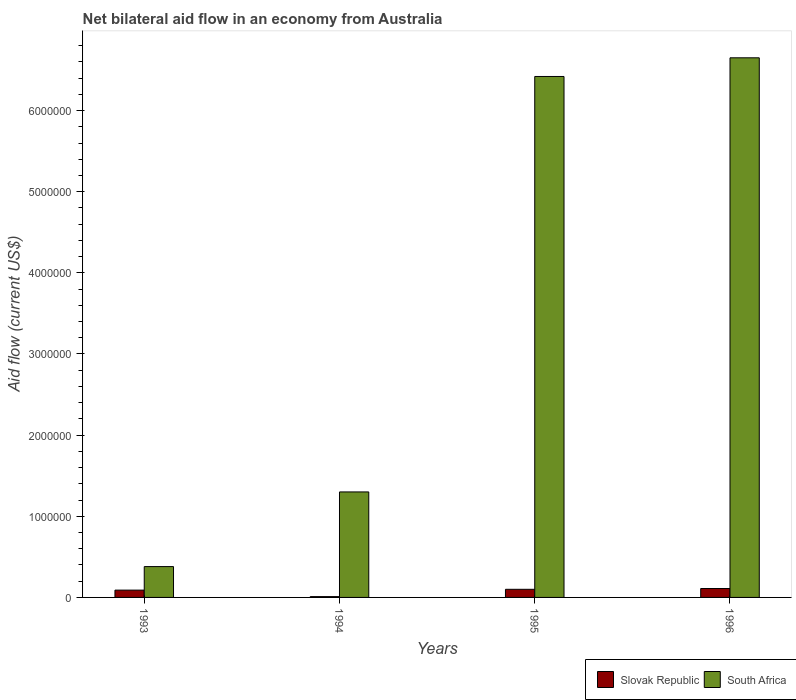Are the number of bars per tick equal to the number of legend labels?
Keep it short and to the point. Yes. How many bars are there on the 1st tick from the right?
Your response must be concise. 2. What is the label of the 1st group of bars from the left?
Your answer should be compact. 1993. Across all years, what is the maximum net bilateral aid flow in Slovak Republic?
Offer a very short reply. 1.10e+05. Across all years, what is the minimum net bilateral aid flow in South Africa?
Your answer should be compact. 3.80e+05. In which year was the net bilateral aid flow in South Africa maximum?
Your answer should be very brief. 1996. What is the total net bilateral aid flow in South Africa in the graph?
Give a very brief answer. 1.48e+07. What is the difference between the net bilateral aid flow in South Africa in 1994 and that in 1995?
Your response must be concise. -5.12e+06. What is the difference between the net bilateral aid flow in South Africa in 1996 and the net bilateral aid flow in Slovak Republic in 1995?
Ensure brevity in your answer.  6.55e+06. What is the average net bilateral aid flow in South Africa per year?
Ensure brevity in your answer.  3.69e+06. In the year 1995, what is the difference between the net bilateral aid flow in Slovak Republic and net bilateral aid flow in South Africa?
Offer a very short reply. -6.32e+06. In how many years, is the net bilateral aid flow in South Africa greater than 3000000 US$?
Provide a short and direct response. 2. What is the ratio of the net bilateral aid flow in South Africa in 1993 to that in 1995?
Provide a succinct answer. 0.06. Is the net bilateral aid flow in Slovak Republic in 1993 less than that in 1996?
Offer a very short reply. Yes. What is the difference between the highest and the second highest net bilateral aid flow in Slovak Republic?
Give a very brief answer. 10000. In how many years, is the net bilateral aid flow in Slovak Republic greater than the average net bilateral aid flow in Slovak Republic taken over all years?
Keep it short and to the point. 3. Is the sum of the net bilateral aid flow in Slovak Republic in 1993 and 1995 greater than the maximum net bilateral aid flow in South Africa across all years?
Give a very brief answer. No. What does the 2nd bar from the left in 1993 represents?
Provide a succinct answer. South Africa. What does the 1st bar from the right in 1993 represents?
Provide a short and direct response. South Africa. How many bars are there?
Your answer should be very brief. 8. What is the difference between two consecutive major ticks on the Y-axis?
Ensure brevity in your answer.  1.00e+06. Does the graph contain any zero values?
Provide a short and direct response. No. What is the title of the graph?
Make the answer very short. Net bilateral aid flow in an economy from Australia. Does "Caribbean small states" appear as one of the legend labels in the graph?
Ensure brevity in your answer.  No. What is the label or title of the Y-axis?
Provide a succinct answer. Aid flow (current US$). What is the Aid flow (current US$) of South Africa in 1993?
Your answer should be very brief. 3.80e+05. What is the Aid flow (current US$) in Slovak Republic in 1994?
Keep it short and to the point. 10000. What is the Aid flow (current US$) in South Africa in 1994?
Ensure brevity in your answer.  1.30e+06. What is the Aid flow (current US$) of Slovak Republic in 1995?
Give a very brief answer. 1.00e+05. What is the Aid flow (current US$) in South Africa in 1995?
Provide a short and direct response. 6.42e+06. What is the Aid flow (current US$) in South Africa in 1996?
Provide a succinct answer. 6.65e+06. Across all years, what is the maximum Aid flow (current US$) of Slovak Republic?
Keep it short and to the point. 1.10e+05. Across all years, what is the maximum Aid flow (current US$) in South Africa?
Your answer should be compact. 6.65e+06. What is the total Aid flow (current US$) in South Africa in the graph?
Your response must be concise. 1.48e+07. What is the difference between the Aid flow (current US$) in South Africa in 1993 and that in 1994?
Provide a succinct answer. -9.20e+05. What is the difference between the Aid flow (current US$) of South Africa in 1993 and that in 1995?
Offer a terse response. -6.04e+06. What is the difference between the Aid flow (current US$) of Slovak Republic in 1993 and that in 1996?
Your answer should be compact. -2.00e+04. What is the difference between the Aid flow (current US$) in South Africa in 1993 and that in 1996?
Offer a terse response. -6.27e+06. What is the difference between the Aid flow (current US$) of South Africa in 1994 and that in 1995?
Your response must be concise. -5.12e+06. What is the difference between the Aid flow (current US$) in Slovak Republic in 1994 and that in 1996?
Give a very brief answer. -1.00e+05. What is the difference between the Aid flow (current US$) of South Africa in 1994 and that in 1996?
Ensure brevity in your answer.  -5.35e+06. What is the difference between the Aid flow (current US$) of Slovak Republic in 1995 and that in 1996?
Offer a terse response. -10000. What is the difference between the Aid flow (current US$) of Slovak Republic in 1993 and the Aid flow (current US$) of South Africa in 1994?
Offer a very short reply. -1.21e+06. What is the difference between the Aid flow (current US$) in Slovak Republic in 1993 and the Aid flow (current US$) in South Africa in 1995?
Offer a terse response. -6.33e+06. What is the difference between the Aid flow (current US$) in Slovak Republic in 1993 and the Aid flow (current US$) in South Africa in 1996?
Make the answer very short. -6.56e+06. What is the difference between the Aid flow (current US$) of Slovak Republic in 1994 and the Aid flow (current US$) of South Africa in 1995?
Provide a short and direct response. -6.41e+06. What is the difference between the Aid flow (current US$) in Slovak Republic in 1994 and the Aid flow (current US$) in South Africa in 1996?
Your response must be concise. -6.64e+06. What is the difference between the Aid flow (current US$) of Slovak Republic in 1995 and the Aid flow (current US$) of South Africa in 1996?
Keep it short and to the point. -6.55e+06. What is the average Aid flow (current US$) of Slovak Republic per year?
Your answer should be very brief. 7.75e+04. What is the average Aid flow (current US$) in South Africa per year?
Offer a very short reply. 3.69e+06. In the year 1993, what is the difference between the Aid flow (current US$) of Slovak Republic and Aid flow (current US$) of South Africa?
Provide a succinct answer. -2.90e+05. In the year 1994, what is the difference between the Aid flow (current US$) in Slovak Republic and Aid flow (current US$) in South Africa?
Keep it short and to the point. -1.29e+06. In the year 1995, what is the difference between the Aid flow (current US$) of Slovak Republic and Aid flow (current US$) of South Africa?
Ensure brevity in your answer.  -6.32e+06. In the year 1996, what is the difference between the Aid flow (current US$) of Slovak Republic and Aid flow (current US$) of South Africa?
Your answer should be very brief. -6.54e+06. What is the ratio of the Aid flow (current US$) in Slovak Republic in 1993 to that in 1994?
Make the answer very short. 9. What is the ratio of the Aid flow (current US$) of South Africa in 1993 to that in 1994?
Ensure brevity in your answer.  0.29. What is the ratio of the Aid flow (current US$) in South Africa in 1993 to that in 1995?
Ensure brevity in your answer.  0.06. What is the ratio of the Aid flow (current US$) of Slovak Republic in 1993 to that in 1996?
Make the answer very short. 0.82. What is the ratio of the Aid flow (current US$) in South Africa in 1993 to that in 1996?
Keep it short and to the point. 0.06. What is the ratio of the Aid flow (current US$) in Slovak Republic in 1994 to that in 1995?
Make the answer very short. 0.1. What is the ratio of the Aid flow (current US$) of South Africa in 1994 to that in 1995?
Make the answer very short. 0.2. What is the ratio of the Aid flow (current US$) of Slovak Republic in 1994 to that in 1996?
Keep it short and to the point. 0.09. What is the ratio of the Aid flow (current US$) in South Africa in 1994 to that in 1996?
Keep it short and to the point. 0.2. What is the ratio of the Aid flow (current US$) of Slovak Republic in 1995 to that in 1996?
Your response must be concise. 0.91. What is the ratio of the Aid flow (current US$) of South Africa in 1995 to that in 1996?
Offer a terse response. 0.97. What is the difference between the highest and the second highest Aid flow (current US$) of Slovak Republic?
Keep it short and to the point. 10000. What is the difference between the highest and the lowest Aid flow (current US$) of South Africa?
Provide a succinct answer. 6.27e+06. 